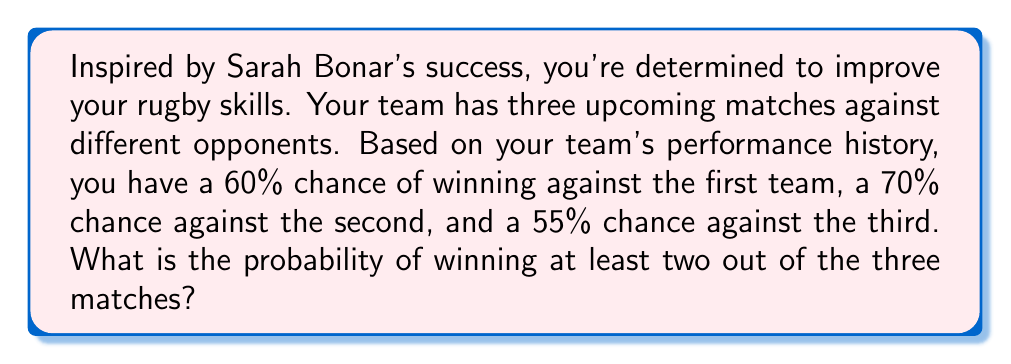Can you answer this question? Let's approach this step-by-step:

1) First, we need to calculate the probability of winning exactly 2 matches and the probability of winning all 3 matches.

2) To win exactly 2 matches, we have three possible scenarios:
   a) Win, Win, Lose
   b) Win, Lose, Win
   c) Lose, Win, Win

3) Let's calculate each:
   a) P(W,W,L) = 0.60 * 0.70 * (1-0.55) = 0.60 * 0.70 * 0.45 = 0.189
   b) P(W,L,W) = 0.60 * (1-0.70) * 0.55 = 0.60 * 0.30 * 0.55 = 0.099
   c) P(L,W,W) = (1-0.60) * 0.70 * 0.55 = 0.40 * 0.70 * 0.55 = 0.154

4) The probability of winning exactly 2 matches is the sum of these:
   P(exactly 2) = 0.189 + 0.099 + 0.154 = 0.442

5) The probability of winning all 3 matches is:
   P(all 3) = 0.60 * 0.70 * 0.55 = 0.231

6) The probability of winning at least 2 matches is the sum of winning exactly 2 and winning all 3:
   P(at least 2) = P(exactly 2) + P(all 3) = 0.442 + 0.231 = 0.673

7) Therefore, the probability of winning at least two out of the three matches is 0.673 or 67.3%.
Answer: 0.673 or 67.3% 